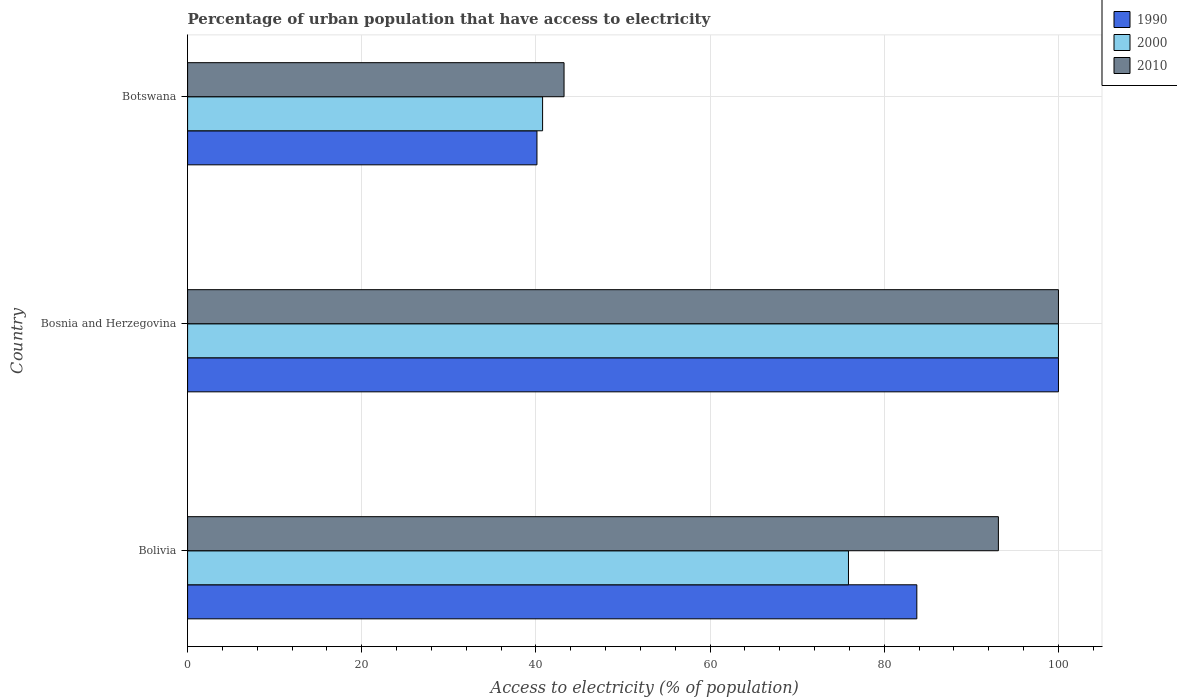How many bars are there on the 3rd tick from the top?
Keep it short and to the point. 3. How many bars are there on the 3rd tick from the bottom?
Your answer should be compact. 3. What is the label of the 2nd group of bars from the top?
Offer a very short reply. Bosnia and Herzegovina. What is the percentage of urban population that have access to electricity in 2010 in Bolivia?
Offer a terse response. 93.1. Across all countries, what is the minimum percentage of urban population that have access to electricity in 2010?
Your response must be concise. 43.23. In which country was the percentage of urban population that have access to electricity in 2010 maximum?
Your answer should be very brief. Bosnia and Herzegovina. In which country was the percentage of urban population that have access to electricity in 2010 minimum?
Your answer should be very brief. Botswana. What is the total percentage of urban population that have access to electricity in 2000 in the graph?
Provide a short and direct response. 216.65. What is the difference between the percentage of urban population that have access to electricity in 2010 in Bolivia and that in Botswana?
Offer a very short reply. 49.88. What is the difference between the percentage of urban population that have access to electricity in 1990 in Bolivia and the percentage of urban population that have access to electricity in 2010 in Bosnia and Herzegovina?
Offer a very short reply. -16.26. What is the average percentage of urban population that have access to electricity in 2000 per country?
Your response must be concise. 72.22. In how many countries, is the percentage of urban population that have access to electricity in 2000 greater than 60 %?
Your response must be concise. 2. What is the ratio of the percentage of urban population that have access to electricity in 1990 in Bosnia and Herzegovina to that in Botswana?
Offer a very short reply. 2.49. Is the percentage of urban population that have access to electricity in 2010 in Bolivia less than that in Botswana?
Your answer should be compact. No. What is the difference between the highest and the second highest percentage of urban population that have access to electricity in 2010?
Your answer should be very brief. 6.9. What is the difference between the highest and the lowest percentage of urban population that have access to electricity in 1990?
Provide a short and direct response. 59.88. What does the 3rd bar from the top in Bolivia represents?
Offer a very short reply. 1990. Is it the case that in every country, the sum of the percentage of urban population that have access to electricity in 1990 and percentage of urban population that have access to electricity in 2000 is greater than the percentage of urban population that have access to electricity in 2010?
Provide a succinct answer. Yes. How many countries are there in the graph?
Provide a short and direct response. 3. Are the values on the major ticks of X-axis written in scientific E-notation?
Provide a succinct answer. No. How are the legend labels stacked?
Offer a very short reply. Vertical. What is the title of the graph?
Your response must be concise. Percentage of urban population that have access to electricity. What is the label or title of the X-axis?
Give a very brief answer. Access to electricity (% of population). What is the label or title of the Y-axis?
Your response must be concise. Country. What is the Access to electricity (% of population) of 1990 in Bolivia?
Ensure brevity in your answer.  83.74. What is the Access to electricity (% of population) of 2000 in Bolivia?
Ensure brevity in your answer.  75.89. What is the Access to electricity (% of population) in 2010 in Bolivia?
Provide a succinct answer. 93.1. What is the Access to electricity (% of population) in 1990 in Bosnia and Herzegovina?
Keep it short and to the point. 100. What is the Access to electricity (% of population) of 1990 in Botswana?
Provide a succinct answer. 40.12. What is the Access to electricity (% of population) in 2000 in Botswana?
Your response must be concise. 40.76. What is the Access to electricity (% of population) in 2010 in Botswana?
Give a very brief answer. 43.23. Across all countries, what is the maximum Access to electricity (% of population) of 1990?
Make the answer very short. 100. Across all countries, what is the maximum Access to electricity (% of population) of 2000?
Keep it short and to the point. 100. Across all countries, what is the minimum Access to electricity (% of population) in 1990?
Your answer should be compact. 40.12. Across all countries, what is the minimum Access to electricity (% of population) in 2000?
Make the answer very short. 40.76. Across all countries, what is the minimum Access to electricity (% of population) of 2010?
Your response must be concise. 43.23. What is the total Access to electricity (% of population) in 1990 in the graph?
Offer a very short reply. 223.85. What is the total Access to electricity (% of population) of 2000 in the graph?
Your answer should be compact. 216.65. What is the total Access to electricity (% of population) in 2010 in the graph?
Make the answer very short. 236.33. What is the difference between the Access to electricity (% of population) of 1990 in Bolivia and that in Bosnia and Herzegovina?
Offer a terse response. -16.26. What is the difference between the Access to electricity (% of population) of 2000 in Bolivia and that in Bosnia and Herzegovina?
Keep it short and to the point. -24.11. What is the difference between the Access to electricity (% of population) in 2010 in Bolivia and that in Bosnia and Herzegovina?
Provide a short and direct response. -6.9. What is the difference between the Access to electricity (% of population) in 1990 in Bolivia and that in Botswana?
Provide a succinct answer. 43.62. What is the difference between the Access to electricity (% of population) of 2000 in Bolivia and that in Botswana?
Ensure brevity in your answer.  35.12. What is the difference between the Access to electricity (% of population) in 2010 in Bolivia and that in Botswana?
Your answer should be very brief. 49.88. What is the difference between the Access to electricity (% of population) of 1990 in Bosnia and Herzegovina and that in Botswana?
Offer a very short reply. 59.88. What is the difference between the Access to electricity (% of population) of 2000 in Bosnia and Herzegovina and that in Botswana?
Make the answer very short. 59.24. What is the difference between the Access to electricity (% of population) in 2010 in Bosnia and Herzegovina and that in Botswana?
Your response must be concise. 56.77. What is the difference between the Access to electricity (% of population) in 1990 in Bolivia and the Access to electricity (% of population) in 2000 in Bosnia and Herzegovina?
Ensure brevity in your answer.  -16.26. What is the difference between the Access to electricity (% of population) in 1990 in Bolivia and the Access to electricity (% of population) in 2010 in Bosnia and Herzegovina?
Your answer should be very brief. -16.26. What is the difference between the Access to electricity (% of population) of 2000 in Bolivia and the Access to electricity (% of population) of 2010 in Bosnia and Herzegovina?
Keep it short and to the point. -24.11. What is the difference between the Access to electricity (% of population) of 1990 in Bolivia and the Access to electricity (% of population) of 2000 in Botswana?
Your answer should be very brief. 42.97. What is the difference between the Access to electricity (% of population) of 1990 in Bolivia and the Access to electricity (% of population) of 2010 in Botswana?
Offer a very short reply. 40.51. What is the difference between the Access to electricity (% of population) in 2000 in Bolivia and the Access to electricity (% of population) in 2010 in Botswana?
Offer a terse response. 32.66. What is the difference between the Access to electricity (% of population) in 1990 in Bosnia and Herzegovina and the Access to electricity (% of population) in 2000 in Botswana?
Provide a short and direct response. 59.24. What is the difference between the Access to electricity (% of population) in 1990 in Bosnia and Herzegovina and the Access to electricity (% of population) in 2010 in Botswana?
Your response must be concise. 56.77. What is the difference between the Access to electricity (% of population) in 2000 in Bosnia and Herzegovina and the Access to electricity (% of population) in 2010 in Botswana?
Provide a succinct answer. 56.77. What is the average Access to electricity (% of population) of 1990 per country?
Provide a short and direct response. 74.62. What is the average Access to electricity (% of population) of 2000 per country?
Your response must be concise. 72.22. What is the average Access to electricity (% of population) of 2010 per country?
Provide a short and direct response. 78.78. What is the difference between the Access to electricity (% of population) in 1990 and Access to electricity (% of population) in 2000 in Bolivia?
Give a very brief answer. 7.85. What is the difference between the Access to electricity (% of population) in 1990 and Access to electricity (% of population) in 2010 in Bolivia?
Keep it short and to the point. -9.37. What is the difference between the Access to electricity (% of population) of 2000 and Access to electricity (% of population) of 2010 in Bolivia?
Keep it short and to the point. -17.22. What is the difference between the Access to electricity (% of population) in 1990 and Access to electricity (% of population) in 2000 in Bosnia and Herzegovina?
Your response must be concise. 0. What is the difference between the Access to electricity (% of population) in 2000 and Access to electricity (% of population) in 2010 in Bosnia and Herzegovina?
Your answer should be compact. 0. What is the difference between the Access to electricity (% of population) in 1990 and Access to electricity (% of population) in 2000 in Botswana?
Ensure brevity in your answer.  -0.65. What is the difference between the Access to electricity (% of population) in 1990 and Access to electricity (% of population) in 2010 in Botswana?
Provide a succinct answer. -3.11. What is the difference between the Access to electricity (% of population) of 2000 and Access to electricity (% of population) of 2010 in Botswana?
Make the answer very short. -2.46. What is the ratio of the Access to electricity (% of population) in 1990 in Bolivia to that in Bosnia and Herzegovina?
Make the answer very short. 0.84. What is the ratio of the Access to electricity (% of population) in 2000 in Bolivia to that in Bosnia and Herzegovina?
Your answer should be very brief. 0.76. What is the ratio of the Access to electricity (% of population) in 1990 in Bolivia to that in Botswana?
Keep it short and to the point. 2.09. What is the ratio of the Access to electricity (% of population) in 2000 in Bolivia to that in Botswana?
Ensure brevity in your answer.  1.86. What is the ratio of the Access to electricity (% of population) of 2010 in Bolivia to that in Botswana?
Your answer should be very brief. 2.15. What is the ratio of the Access to electricity (% of population) of 1990 in Bosnia and Herzegovina to that in Botswana?
Provide a succinct answer. 2.49. What is the ratio of the Access to electricity (% of population) in 2000 in Bosnia and Herzegovina to that in Botswana?
Give a very brief answer. 2.45. What is the ratio of the Access to electricity (% of population) in 2010 in Bosnia and Herzegovina to that in Botswana?
Provide a succinct answer. 2.31. What is the difference between the highest and the second highest Access to electricity (% of population) of 1990?
Offer a very short reply. 16.26. What is the difference between the highest and the second highest Access to electricity (% of population) in 2000?
Make the answer very short. 24.11. What is the difference between the highest and the second highest Access to electricity (% of population) in 2010?
Ensure brevity in your answer.  6.9. What is the difference between the highest and the lowest Access to electricity (% of population) in 1990?
Your response must be concise. 59.88. What is the difference between the highest and the lowest Access to electricity (% of population) of 2000?
Keep it short and to the point. 59.24. What is the difference between the highest and the lowest Access to electricity (% of population) of 2010?
Your answer should be compact. 56.77. 